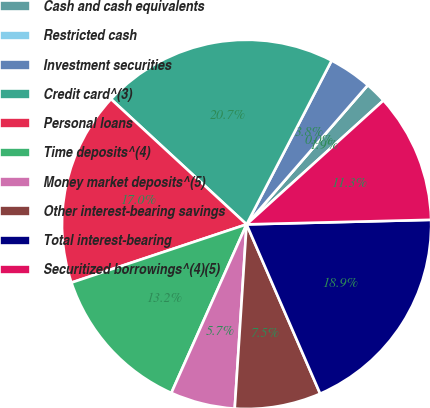Convert chart. <chart><loc_0><loc_0><loc_500><loc_500><pie_chart><fcel>Cash and cash equivalents<fcel>Restricted cash<fcel>Investment securities<fcel>Credit card^(3)<fcel>Personal loans<fcel>Time deposits^(4)<fcel>Money market deposits^(5)<fcel>Other interest-bearing savings<fcel>Total interest-bearing<fcel>Securitized borrowings^(4)(5)<nl><fcel>1.89%<fcel>0.0%<fcel>3.78%<fcel>20.75%<fcel>16.98%<fcel>13.21%<fcel>5.66%<fcel>7.55%<fcel>18.87%<fcel>11.32%<nl></chart> 